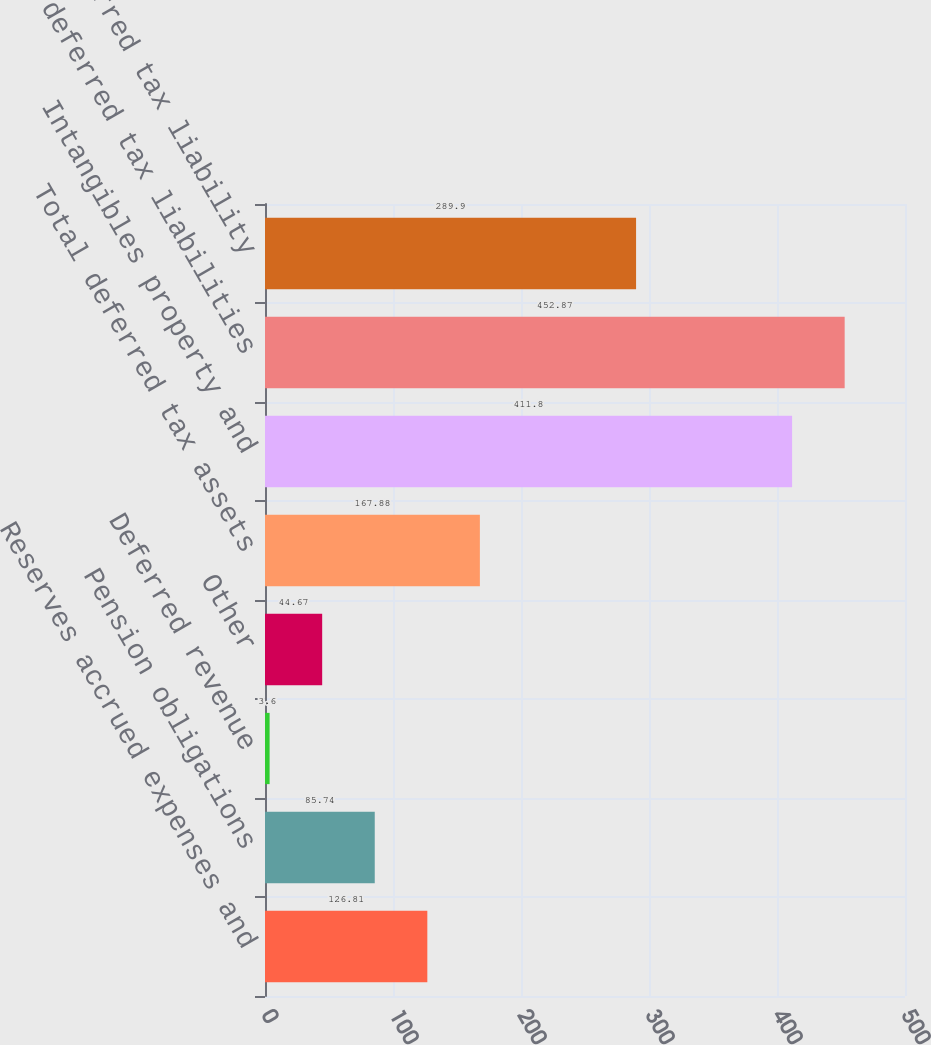Convert chart to OTSL. <chart><loc_0><loc_0><loc_500><loc_500><bar_chart><fcel>Reserves accrued expenses and<fcel>Pension obligations<fcel>Deferred revenue<fcel>Other<fcel>Total deferred tax assets<fcel>Intangibles property and<fcel>Total deferred tax liabilities<fcel>Net deferred tax liability<nl><fcel>126.81<fcel>85.74<fcel>3.6<fcel>44.67<fcel>167.88<fcel>411.8<fcel>452.87<fcel>289.9<nl></chart> 